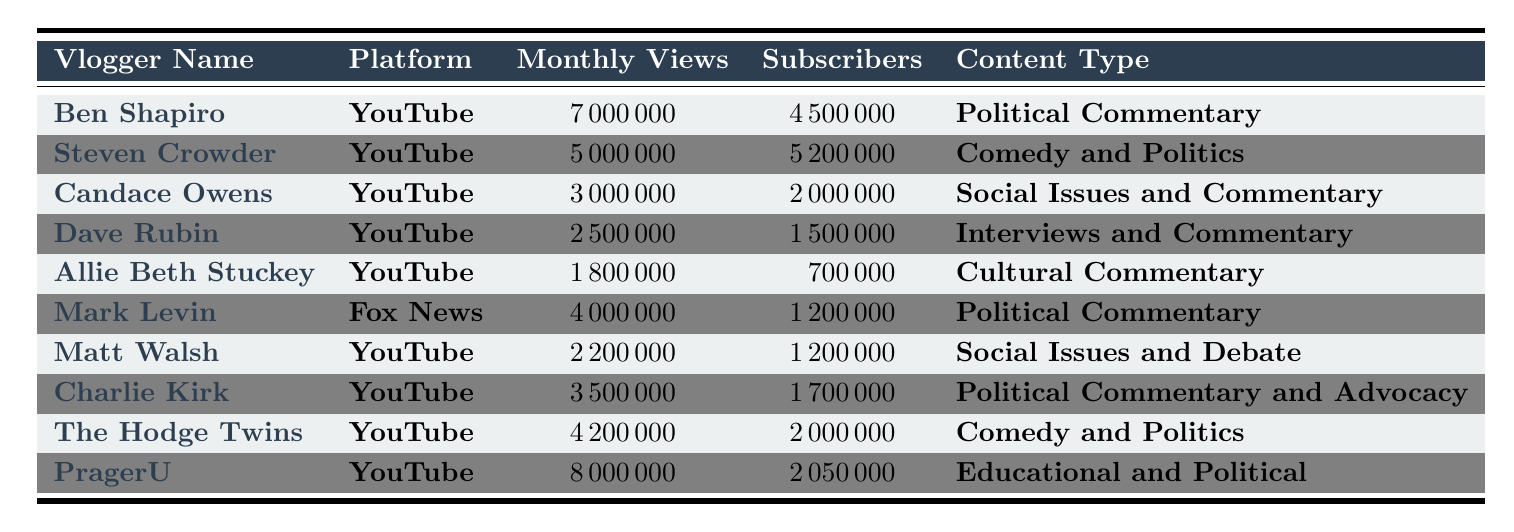What is the name of the vlogger with the highest monthly views? By reviewing the table, the vlogger with the highest monthly views is Ben Shapiro with 7,000,000 views.
Answer: Ben Shapiro How many subscribers does Candace Owens have? The table indicates that Candace Owens has 2,000,000 subscribers.
Answer: 2,000,000 Which platform has the most vloggers listed in the table? All the vloggers except for Mark Levin are on YouTube, while Mark Levin is on Fox News; thus, YouTube has the most vloggers listed.
Answer: YouTube What is the total number of monthly views for all vloggers in the table? Adding the monthly views: 7,000,000 + 5,000,000 + 3,000,000 + 2,500,000 + 1,800,000 + 4,000,000 + 2,200,000 + 3,500,000 + 4,200,000 + 8,000,000 = 41,200,000.
Answer: 41,200,000 Is Dave Rubin's content focused on social issues? According to the table, Dave Rubin's content is categorized as "Interviews and Commentary," which does not primarily focus on social issues. Therefore, the statement is false.
Answer: No Which vlogger has the least number of monthly views? The table shows Allie Beth Stuckey with 1,800,000 monthly views, lower than all other vloggers listed.
Answer: Allie Beth Stuckey What is the average number of subscribers for the vloggers listed in the table? To find the average, we first sum the subscribers: 4,500,000 + 5,200,000 + 2,000,000 + 1,500,000 + 700,000 + 1,200,000 + 1,200,000 + 1,700,000 + 2,000,000 + 2,050,000 = 22,150,000. There are 10 vloggers, so 22,150,000 / 10 = 2,215,000.
Answer: 2,215,000 Which vlogger produces educational content? The table specifies that PragerU's content is "Educational and Political," confirming it produces educational content.
Answer: PragerU What is the difference in monthly views between Ben Shapiro and Matt Walsh? Ben Shapiro has 7,000,000 views while Matt Walsh has 2,200,000 views; the difference is 7,000,000 - 2,200,000 = 4,800,000.
Answer: 4,800,000 Is there a vlogger who covers both comedy and politics? The table lists Steven Crowder and The Hodge Twins as vloggers that cover both comedy and politics, making the statement true.
Answer: Yes 